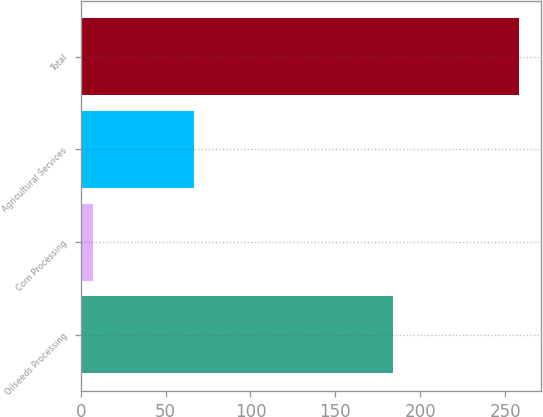<chart> <loc_0><loc_0><loc_500><loc_500><bar_chart><fcel>Oilseeds Processing<fcel>Corn Processing<fcel>Agricultural Services<fcel>Total<nl><fcel>184<fcel>7<fcel>67<fcel>258<nl></chart> 